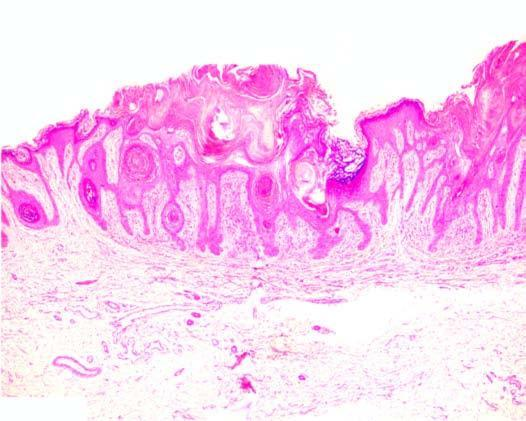what is in a straight line from the normal uninvolved epidermis?
Answer the question using a single word or phrase. Border of the elevated lesion at the lateral margin 